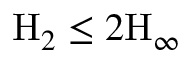Convert formula to latex. <formula><loc_0><loc_0><loc_500><loc_500>H _ { 2 } \leq 2 H _ { \infty }</formula> 